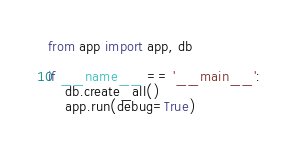<code> <loc_0><loc_0><loc_500><loc_500><_Python_>from app import app, db

if __name__ == '__main__':
    db.create_all()
    app.run(debug=True)
    </code> 